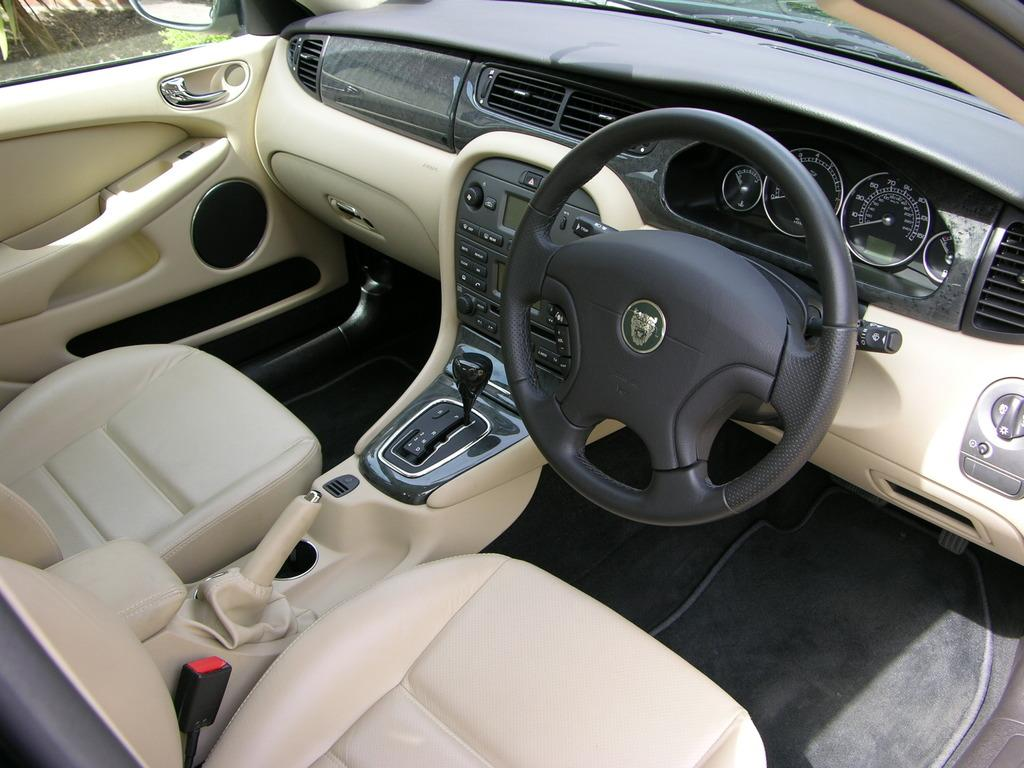What type of setting is depicted in the image? The image shows the interior of a car. How many minutes does it take for the sleet to accumulate on the car's windshield in the image? There is no sleet present in the image, as it shows the interior of a car. 